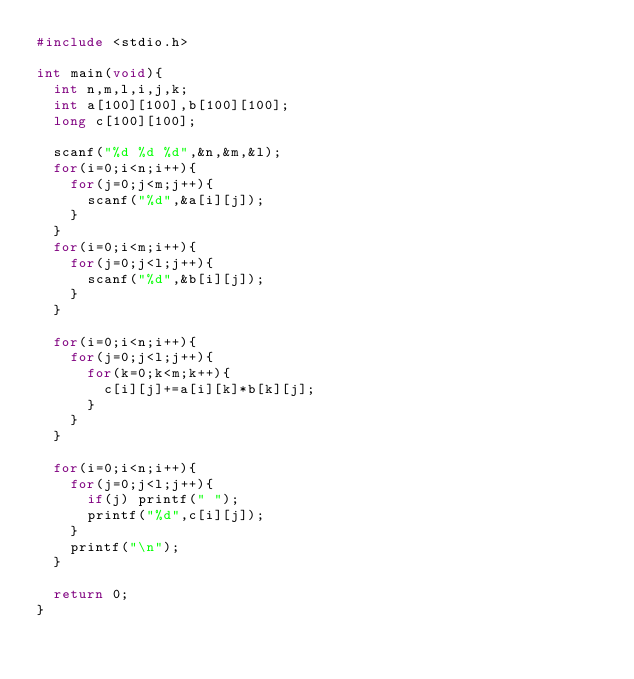<code> <loc_0><loc_0><loc_500><loc_500><_C_>#include <stdio.h>

int main(void){
	int n,m,l,i,j,k;
	int a[100][100],b[100][100];
	long c[100][100];
	
	scanf("%d %d %d",&n,&m,&l);
	for(i=0;i<n;i++){
		for(j=0;j<m;j++){
			scanf("%d",&a[i][j]);
		}
	}
	for(i=0;i<m;i++){
		for(j=0;j<l;j++){
			scanf("%d",&b[i][j]);
		}
	}
	
	for(i=0;i<n;i++){
		for(j=0;j<l;j++){
			for(k=0;k<m;k++){
				c[i][j]+=a[i][k]*b[k][j];
			}
		}
	}
	
	for(i=0;i<n;i++){
		for(j=0;j<l;j++){
			if(j) printf(" ");
			printf("%d",c[i][j]);
		}
		printf("\n");
	}
	
	return 0;
}</code> 